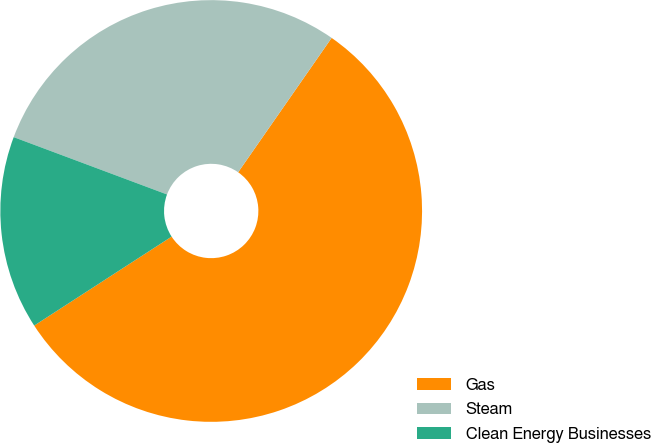Convert chart to OTSL. <chart><loc_0><loc_0><loc_500><loc_500><pie_chart><fcel>Gas<fcel>Steam<fcel>Clean Energy Businesses<nl><fcel>56.18%<fcel>28.98%<fcel>14.84%<nl></chart> 